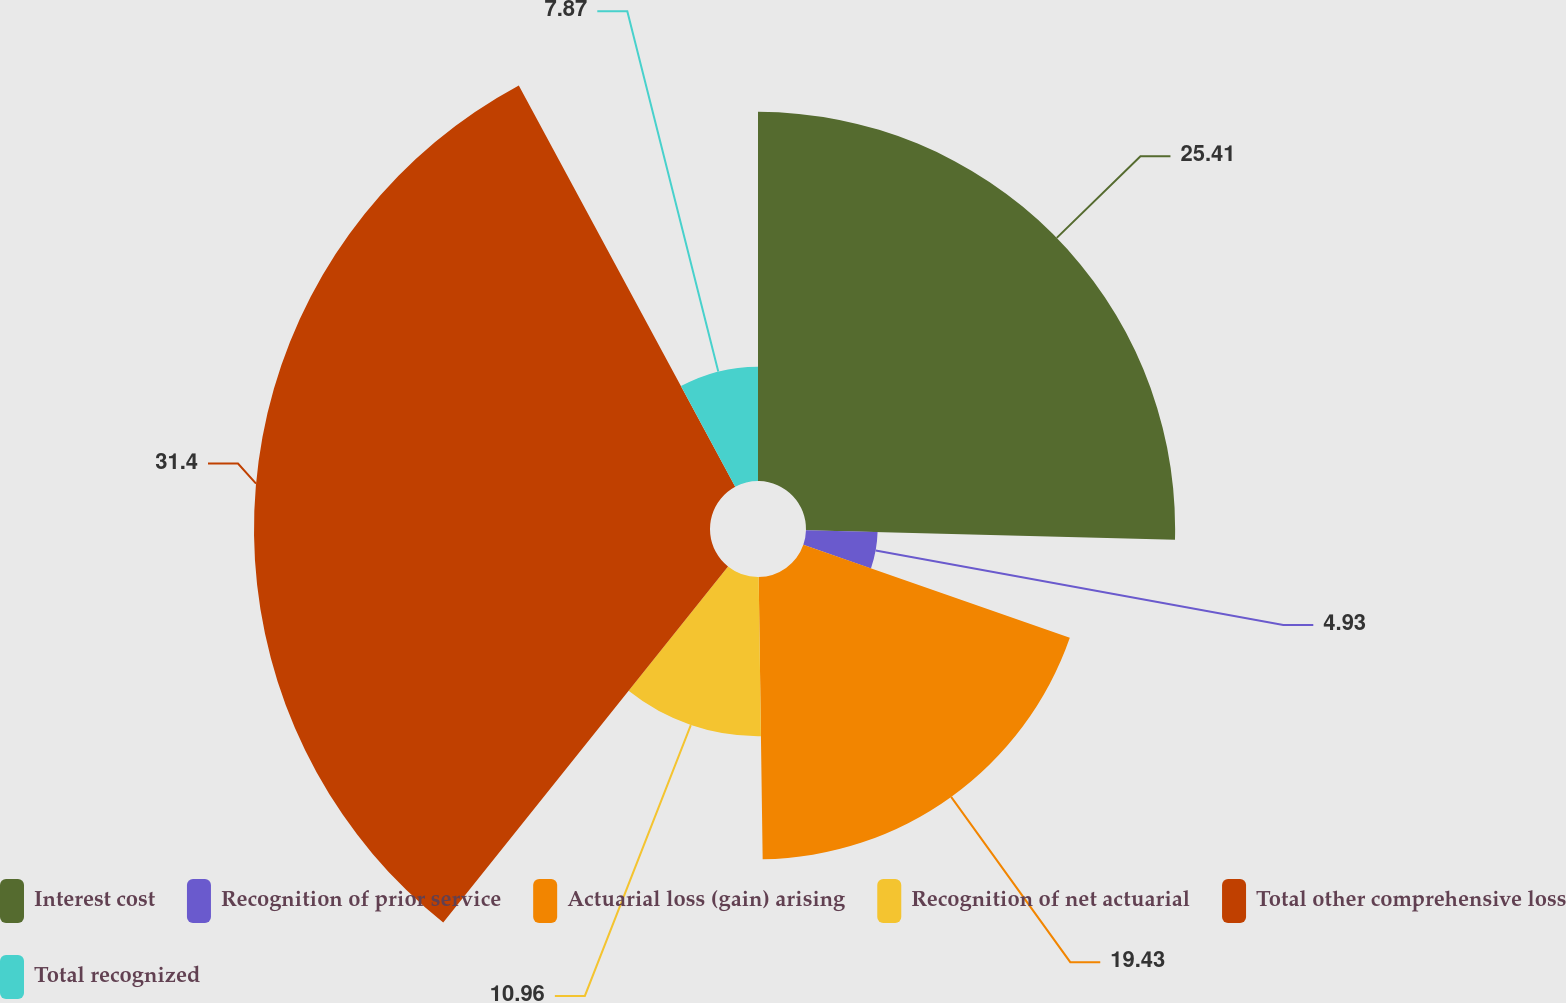Convert chart to OTSL. <chart><loc_0><loc_0><loc_500><loc_500><pie_chart><fcel>Interest cost<fcel>Recognition of prior service<fcel>Actuarial loss (gain) arising<fcel>Recognition of net actuarial<fcel>Total other comprehensive loss<fcel>Total recognized<nl><fcel>25.41%<fcel>4.93%<fcel>19.43%<fcel>10.96%<fcel>31.39%<fcel>7.87%<nl></chart> 